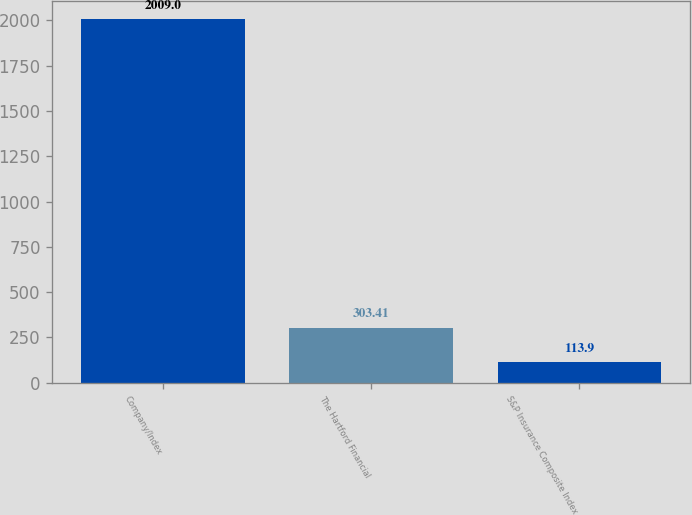<chart> <loc_0><loc_0><loc_500><loc_500><bar_chart><fcel>Company/Index<fcel>The Hartford Financial<fcel>S&P Insurance Composite Index<nl><fcel>2009<fcel>303.41<fcel>113.9<nl></chart> 